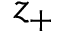Convert formula to latex. <formula><loc_0><loc_0><loc_500><loc_500>z _ { + }</formula> 